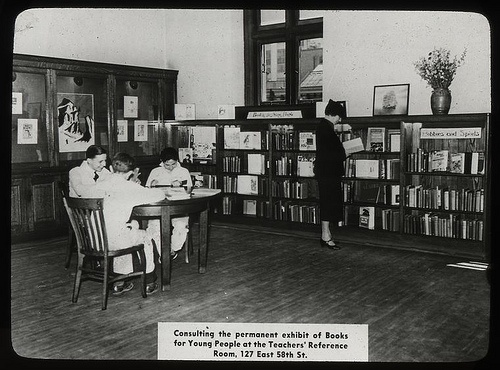Describe the objects in this image and their specific colors. I can see book in black, gray, and darkgray tones, people in black, lightgray, darkgray, and gray tones, people in black, gray, and darkgray tones, dining table in black, gray, and darkgray tones, and chair in black, gray, darkgray, and lightgray tones in this image. 